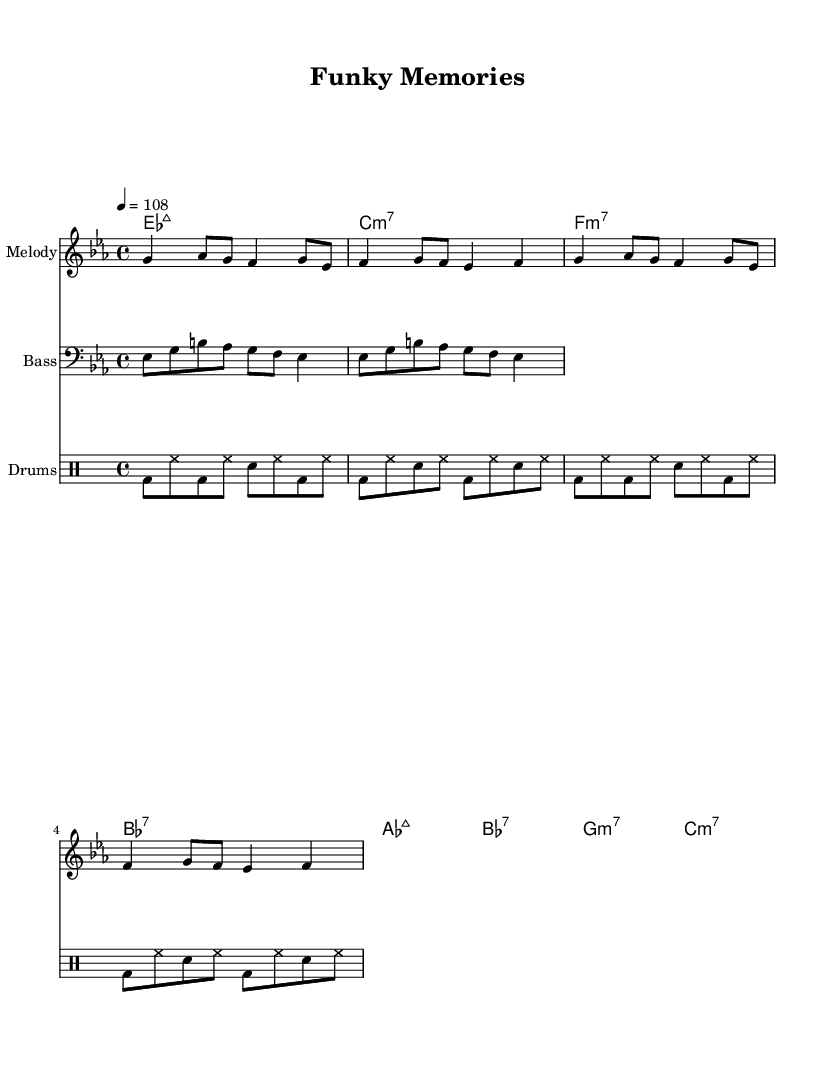What is the key signature of this music? The key signature is E flat major, indicated by three flats (B flat, E flat, and A flat) in the staff's key signature.
Answer: E flat major What is the time signature of this music? The time signature is 4/4, shown at the beginning of the score. This indicates four beats per measure, with each beat a quarter note.
Answer: 4/4 What is the tempo marking for this piece? The tempo marking states "4 = 108," meaning that there are 108 beats per minute and the quarter note gets the beat.
Answer: 108 Which instrument plays the bass line? The bass line is written in the bass clef, indicating that it is played by a bass instrument.
Answer: Bass How many measures does the melody section have? The melody is repeated twice, with each repeat containing four measures; therefore, there are a total of eight measures in the melody section.
Answer: 8 What is the structure of the chords used in this piece? The chord progression contains major and minor seventh chords, specifically emphasizing a jazzy funk characteristic inherent in the 1970s style.
Answer: Major and minor seventh chords What rhythmic pattern do the drums follow? The drums exhibit a repeated alternating pattern of bass and snare hits, typical of funk rhythms, providing a continuous groove throughout the piece.
Answer: Alternating bass and snare pattern 